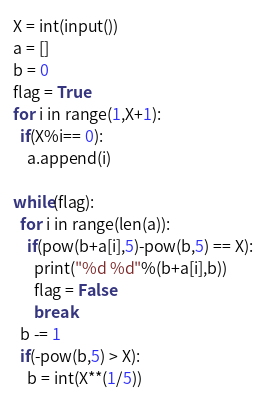<code> <loc_0><loc_0><loc_500><loc_500><_Python_>X = int(input())
a = []
b = 0
flag = True
for i in range(1,X+1):
  if(X%i== 0):
    a.append(i)
  
while(flag):
  for i in range(len(a)): 
    if(pow(b+a[i],5)-pow(b,5) == X):
      print("%d %d"%(b+a[i],b))
      flag = False
      break
  b -= 1
  if(-pow(b,5) > X):
    b = int(X**(1/5))</code> 